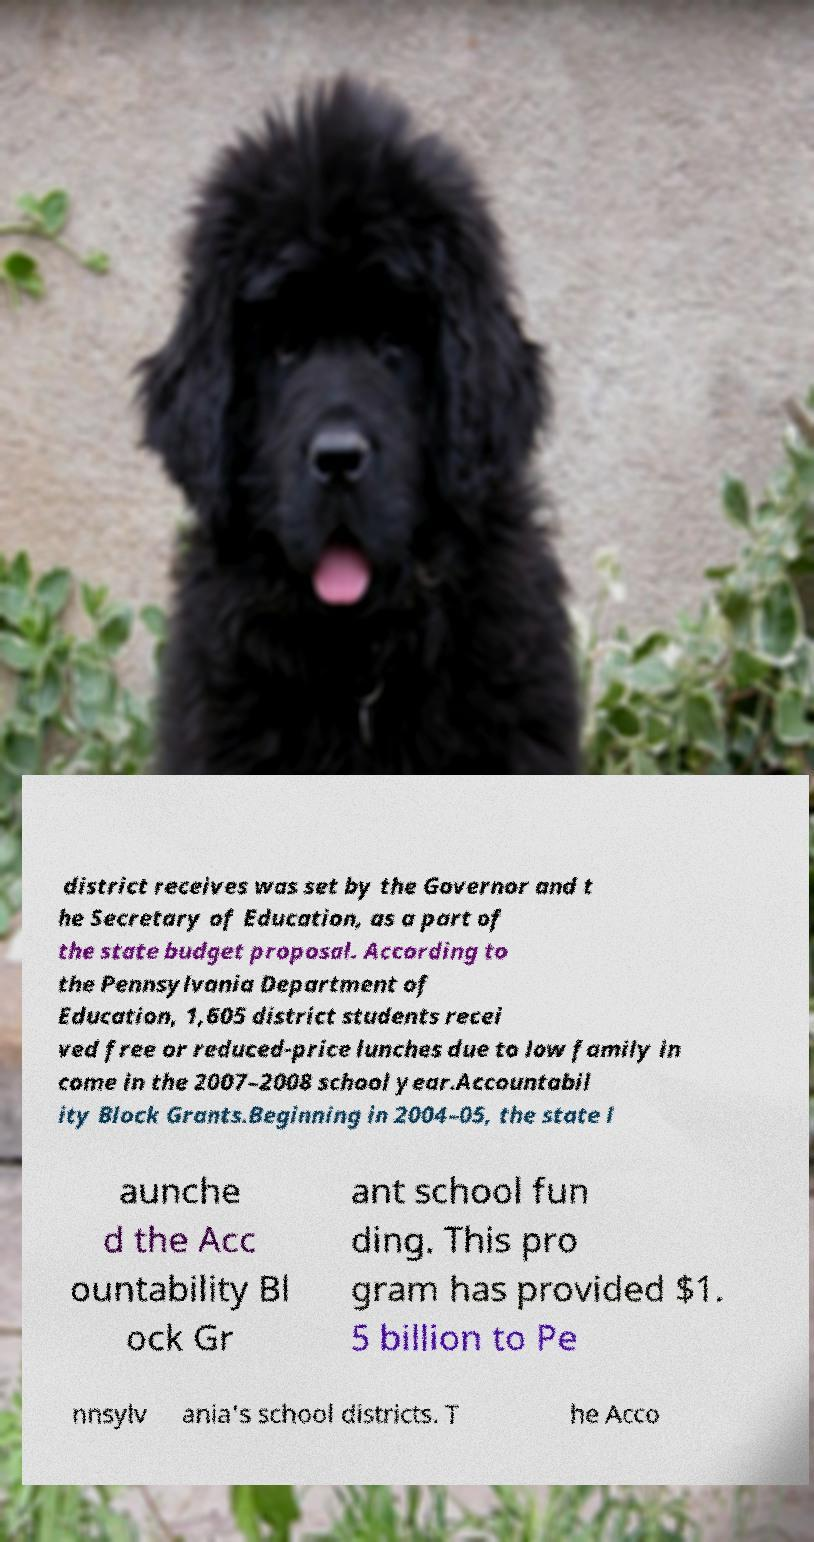Could you assist in decoding the text presented in this image and type it out clearly? district receives was set by the Governor and t he Secretary of Education, as a part of the state budget proposal. According to the Pennsylvania Department of Education, 1,605 district students recei ved free or reduced-price lunches due to low family in come in the 2007–2008 school year.Accountabil ity Block Grants.Beginning in 2004–05, the state l aunche d the Acc ountability Bl ock Gr ant school fun ding. This pro gram has provided $1. 5 billion to Pe nnsylv ania's school districts. T he Acco 